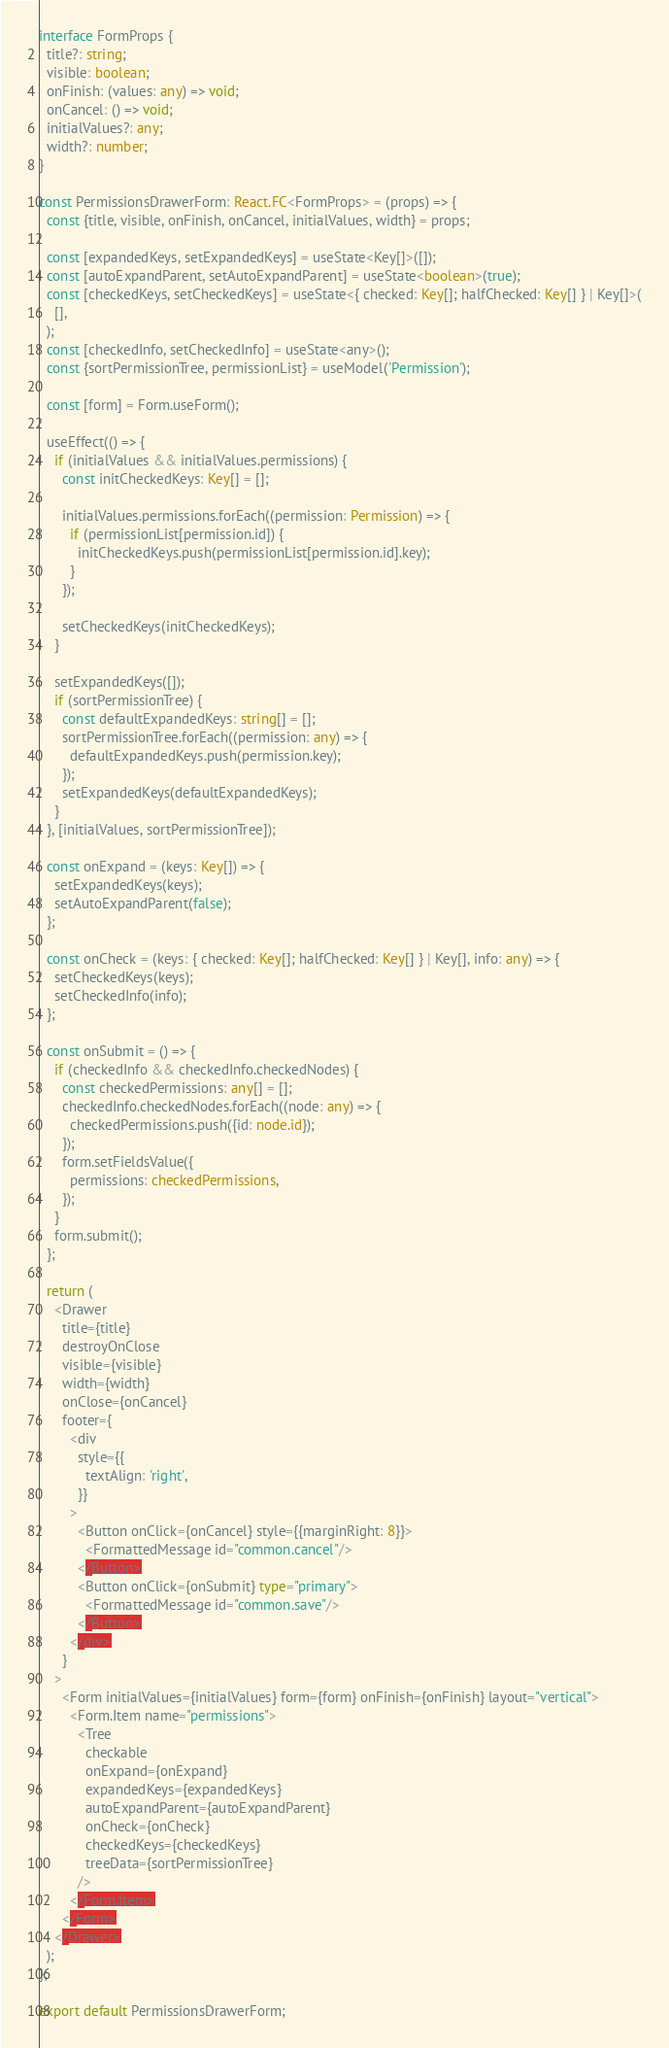<code> <loc_0><loc_0><loc_500><loc_500><_TypeScript_>interface FormProps {
  title?: string;
  visible: boolean;
  onFinish: (values: any) => void;
  onCancel: () => void;
  initialValues?: any;
  width?: number;
}

const PermissionsDrawerForm: React.FC<FormProps> = (props) => {
  const {title, visible, onFinish, onCancel, initialValues, width} = props;

  const [expandedKeys, setExpandedKeys] = useState<Key[]>([]);
  const [autoExpandParent, setAutoExpandParent] = useState<boolean>(true);
  const [checkedKeys, setCheckedKeys] = useState<{ checked: Key[]; halfChecked: Key[] } | Key[]>(
    [],
  );
  const [checkedInfo, setCheckedInfo] = useState<any>();
  const {sortPermissionTree, permissionList} = useModel('Permission');

  const [form] = Form.useForm();

  useEffect(() => {
    if (initialValues && initialValues.permissions) {
      const initCheckedKeys: Key[] = [];

      initialValues.permissions.forEach((permission: Permission) => {
        if (permissionList[permission.id]) {
          initCheckedKeys.push(permissionList[permission.id].key);
        }
      });

      setCheckedKeys(initCheckedKeys);
    }

    setExpandedKeys([]);
    if (sortPermissionTree) {
      const defaultExpandedKeys: string[] = [];
      sortPermissionTree.forEach((permission: any) => {
        defaultExpandedKeys.push(permission.key);
      });
      setExpandedKeys(defaultExpandedKeys);
    }
  }, [initialValues, sortPermissionTree]);

  const onExpand = (keys: Key[]) => {
    setExpandedKeys(keys);
    setAutoExpandParent(false);
  };

  const onCheck = (keys: { checked: Key[]; halfChecked: Key[] } | Key[], info: any) => {
    setCheckedKeys(keys);
    setCheckedInfo(info);
  };

  const onSubmit = () => {
    if (checkedInfo && checkedInfo.checkedNodes) {
      const checkedPermissions: any[] = [];
      checkedInfo.checkedNodes.forEach((node: any) => {
        checkedPermissions.push({id: node.id});
      });
      form.setFieldsValue({
        permissions: checkedPermissions,
      });
    }
    form.submit();
  };

  return (
    <Drawer
      title={title}
      destroyOnClose
      visible={visible}
      width={width}
      onClose={onCancel}
      footer={
        <div
          style={{
            textAlign: 'right',
          }}
        >
          <Button onClick={onCancel} style={{marginRight: 8}}>
            <FormattedMessage id="common.cancel"/>
          </Button>
          <Button onClick={onSubmit} type="primary">
            <FormattedMessage id="common.save"/>
          </Button>
        </div>
      }
    >
      <Form initialValues={initialValues} form={form} onFinish={onFinish} layout="vertical">
        <Form.Item name="permissions">
          <Tree
            checkable
            onExpand={onExpand}
            expandedKeys={expandedKeys}
            autoExpandParent={autoExpandParent}
            onCheck={onCheck}
            checkedKeys={checkedKeys}
            treeData={sortPermissionTree}
          />
        </Form.Item>
      </Form>
    </Drawer>
  );
};

export default PermissionsDrawerForm;
</code> 